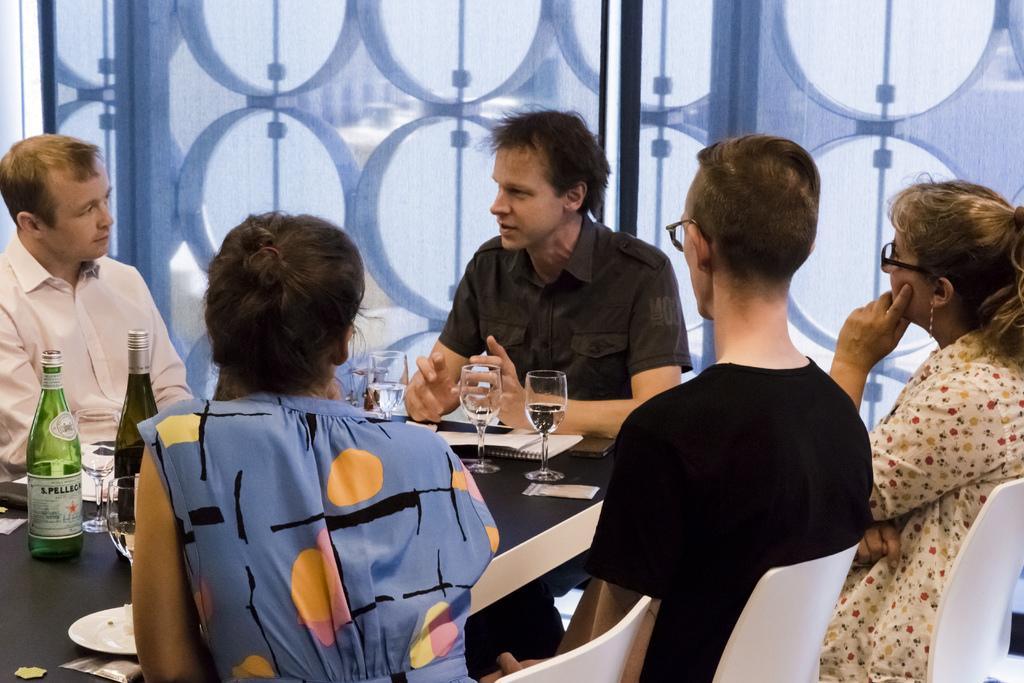Could you give a brief overview of what you see in this image? Here we can see that group of people sitting on the chair and in front there are wine bottles and glasses on the tables and some other objects on it. 